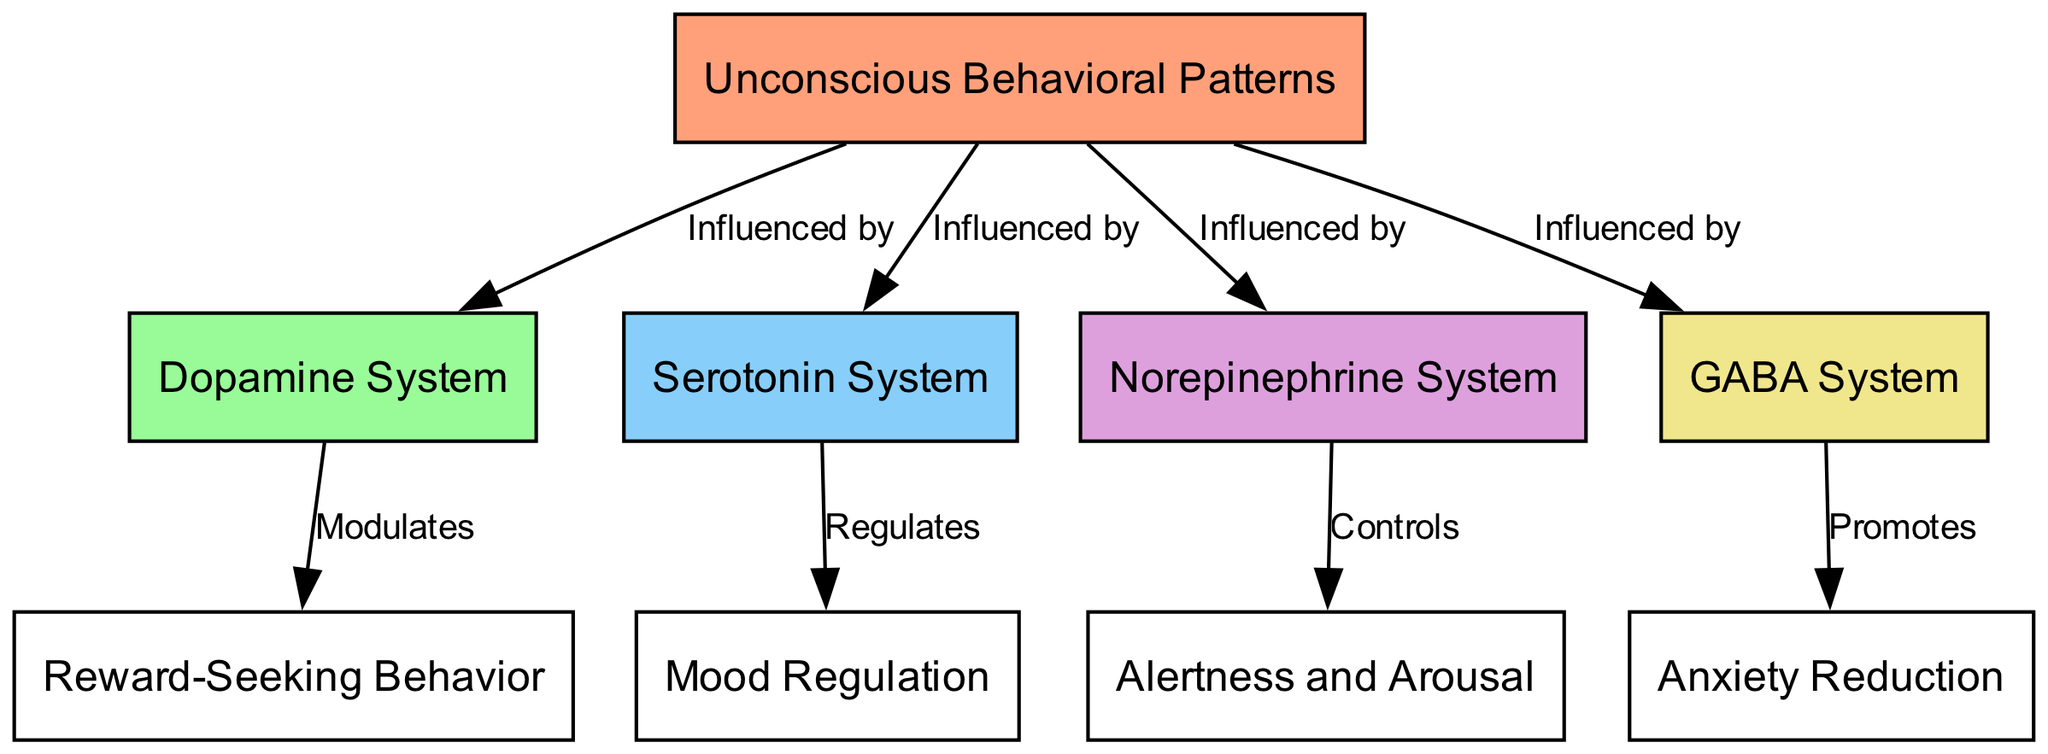What is the main focus of this concept map? The main focus of the concept map is "Unconscious Behavioral Patterns," which is represented as the central node from which other nodes derive and connect.
Answer: Unconscious Behavioral Patterns How many neurotransmitter systems are represented in the diagram? There are four neurotransmitter systems represented: Dopamine System, Serotonin System, Norepinephrine System, and GABA System. Count the nodes labeled as systems to reach this answer.
Answer: 4 Which neurotransmitter system is linked to Reward-Seeking Behavior? The Dopamine System is linked to Reward-Seeking Behavior, as indicated by the edge labeled "Modulates" connecting them.
Answer: Dopamine System What does the Serotonin System regulate? The Serotonin System regulates Mood Regulation, as shown by the direct connection labeled "Regulates" between the two nodes.
Answer: Mood Regulation What system promotes anxiety reduction? The GABA System promotes Anxiety Reduction, as indicated by the edge labeled "Promotes" connecting them.
Answer: GABA System Which system controls alertness and arousal? The Norepinephrine System controls Alertness and Arousal, as shown by the edge labeled "Controls" connecting these two nodes in the diagram.
Answer: Norepinephrine System What relationship exists between the GABA System and the unconscious behavioral patterns? The GABA System is influenced by Unconscious Behavioral Patterns, as demonstrated by the edge labeled "Influenced by" that connects these two nodes.
Answer: Influenced by What is the interrelation between all neurotransmitter systems and unconscious behavioral patterns? All neurotransmitter systems (Dopamine, Serotonin, Norepinephrine, and GABA) influence unconscious behavioral patterns, which demonstrates their interconnected roles in shaping behavior.
Answer: Influence Which system is involved in anxiety reduction? The GABA System is involved in anxiety reduction, as indicated by the direct connection showing its role in promoting this behavior.
Answer: GABA System 